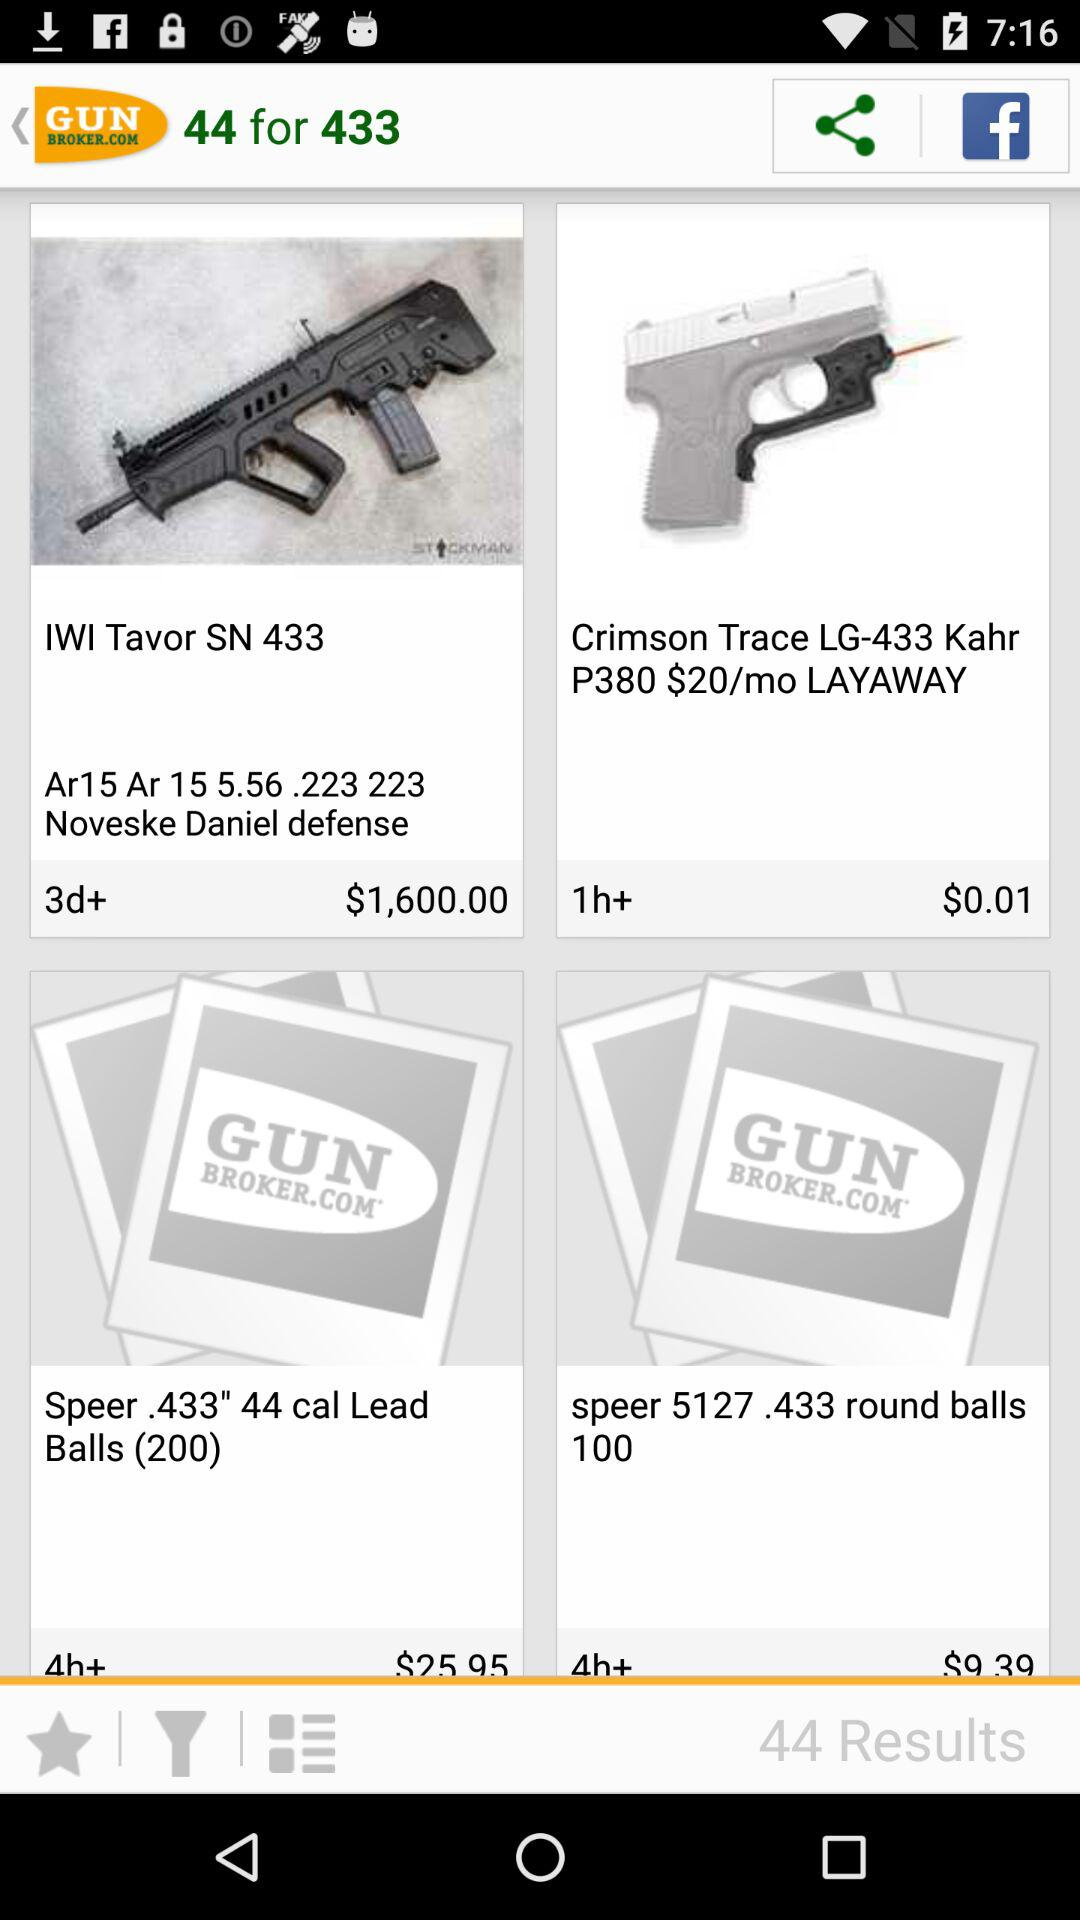What is the price of an "IWI Tavor SN 433" gun? The price of an "IWI Tavor SN 433" gun is $1,600. 